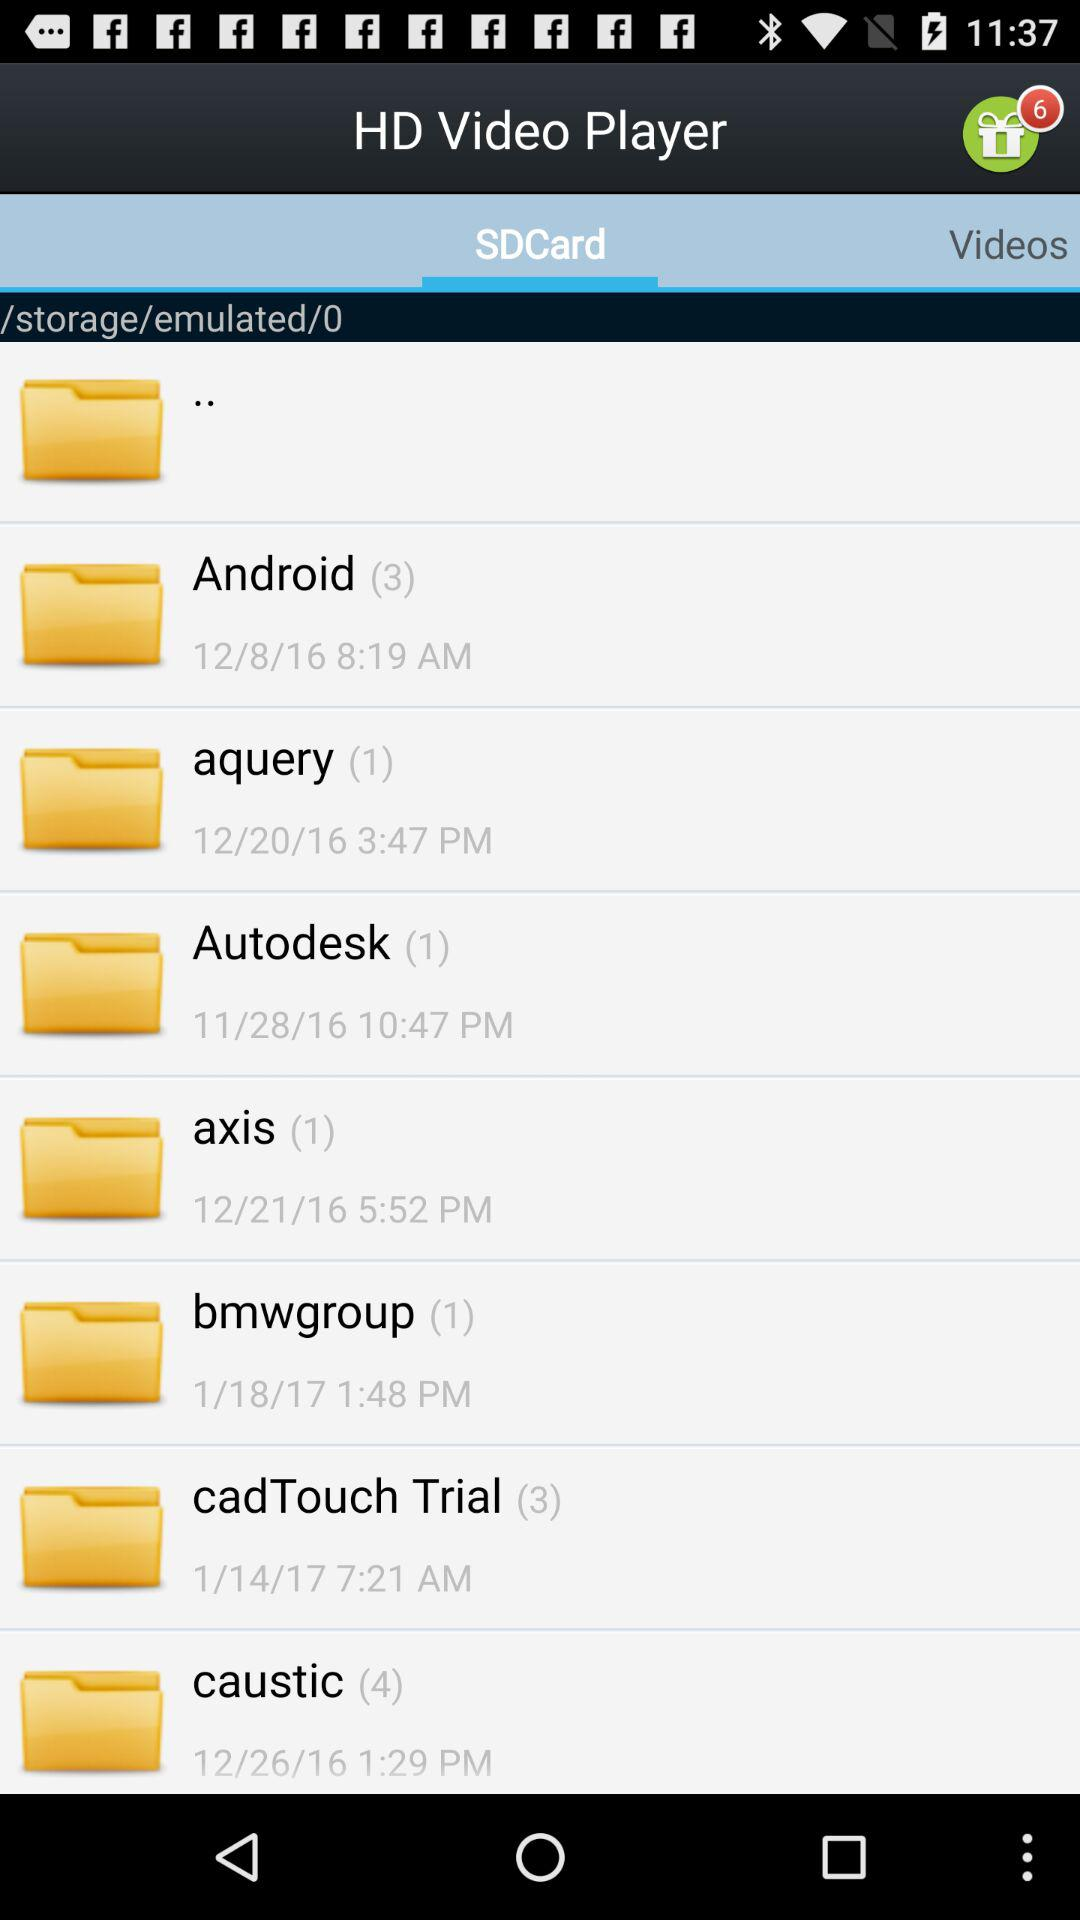How many files are in the "Caustic" folder? There are 4 files. 